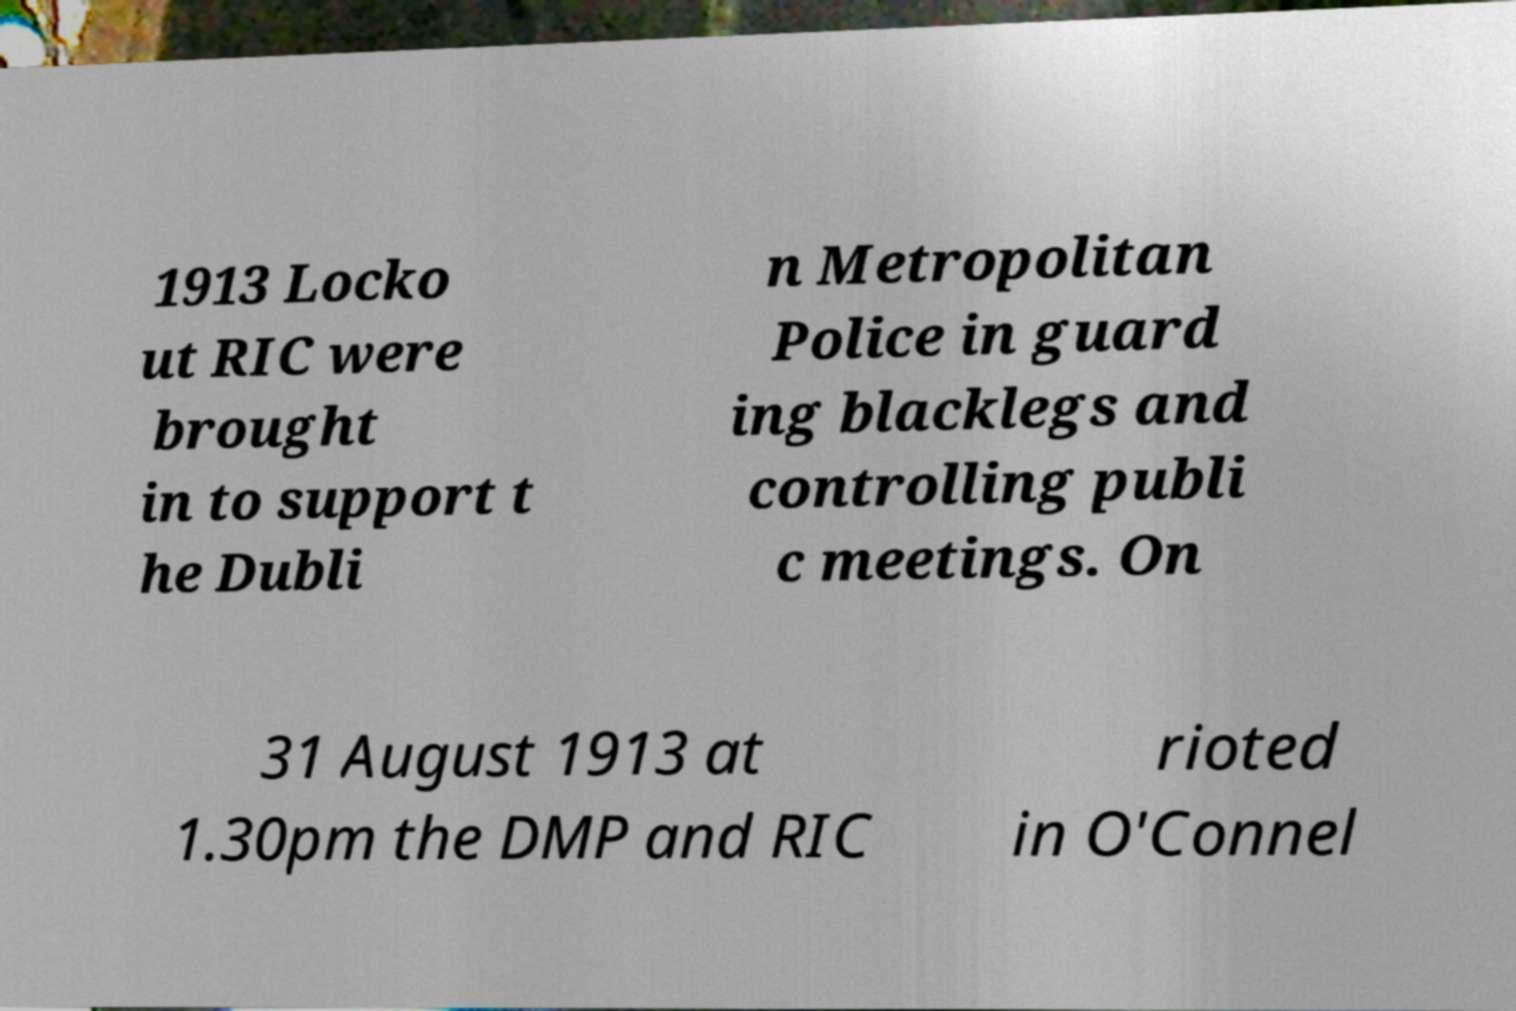There's text embedded in this image that I need extracted. Can you transcribe it verbatim? 1913 Locko ut RIC were brought in to support t he Dubli n Metropolitan Police in guard ing blacklegs and controlling publi c meetings. On 31 August 1913 at 1.30pm the DMP and RIC rioted in O'Connel 